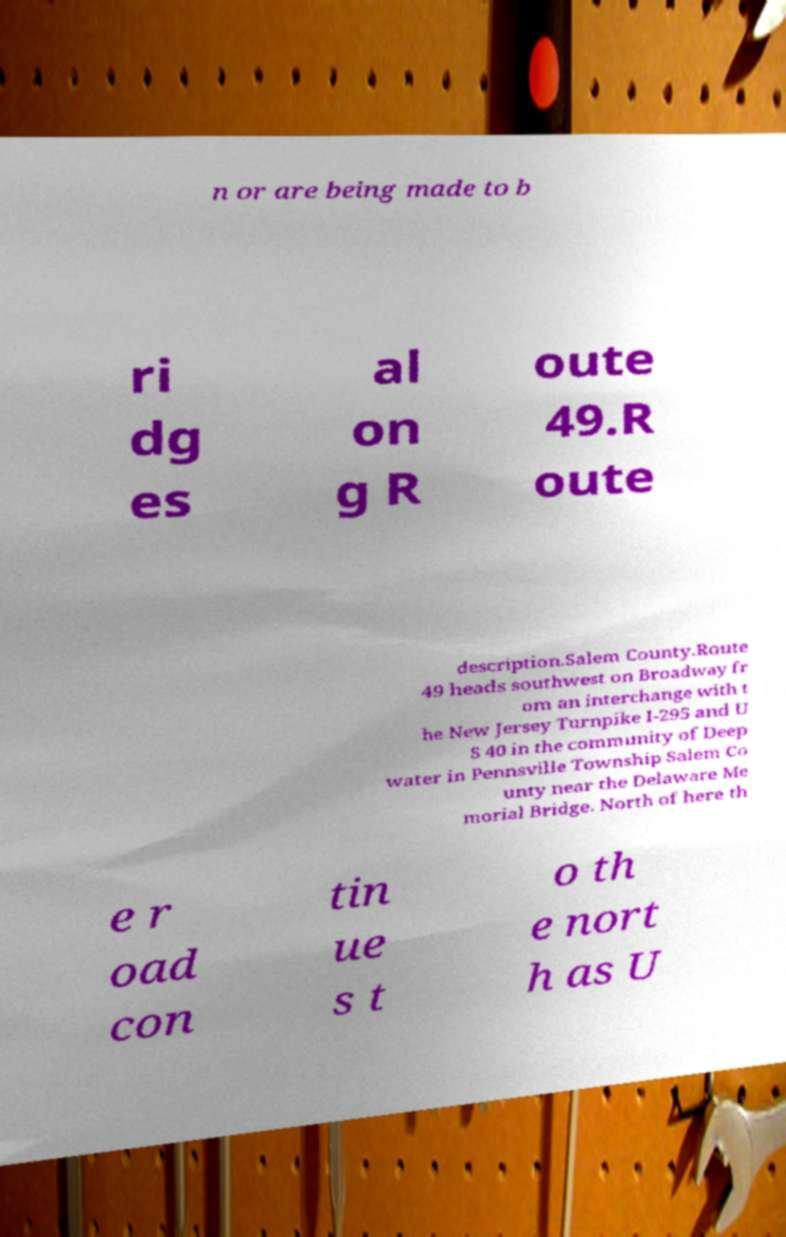Please read and relay the text visible in this image. What does it say? n or are being made to b ri dg es al on g R oute 49.R oute description.Salem County.Route 49 heads southwest on Broadway fr om an interchange with t he New Jersey Turnpike I-295 and U S 40 in the community of Deep water in Pennsville Township Salem Co unty near the Delaware Me morial Bridge. North of here th e r oad con tin ue s t o th e nort h as U 